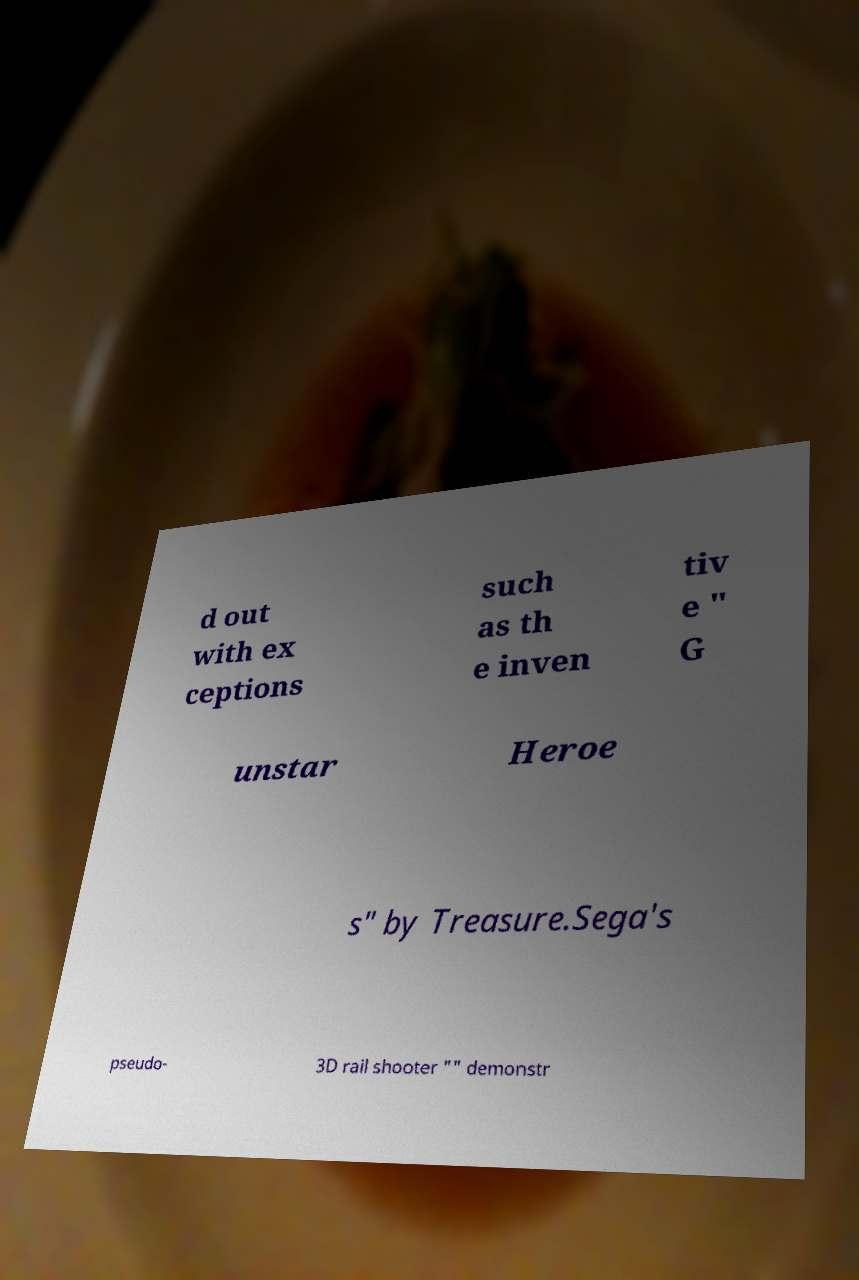Please read and relay the text visible in this image. What does it say? d out with ex ceptions such as th e inven tiv e " G unstar Heroe s" by Treasure.Sega's pseudo- 3D rail shooter "" demonstr 